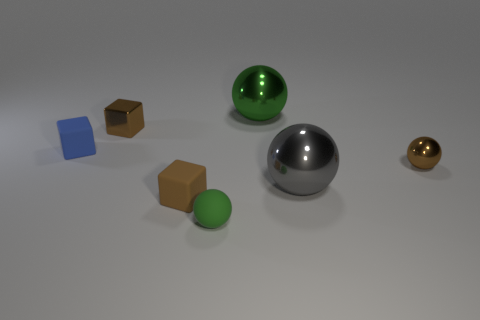Add 1 tiny brown shiny balls. How many objects exist? 8 Subtract all blocks. How many objects are left? 4 Add 5 brown balls. How many brown balls are left? 6 Add 6 gray matte spheres. How many gray matte spheres exist? 6 Subtract 0 gray cylinders. How many objects are left? 7 Subtract all blue rubber objects. Subtract all big green rubber objects. How many objects are left? 6 